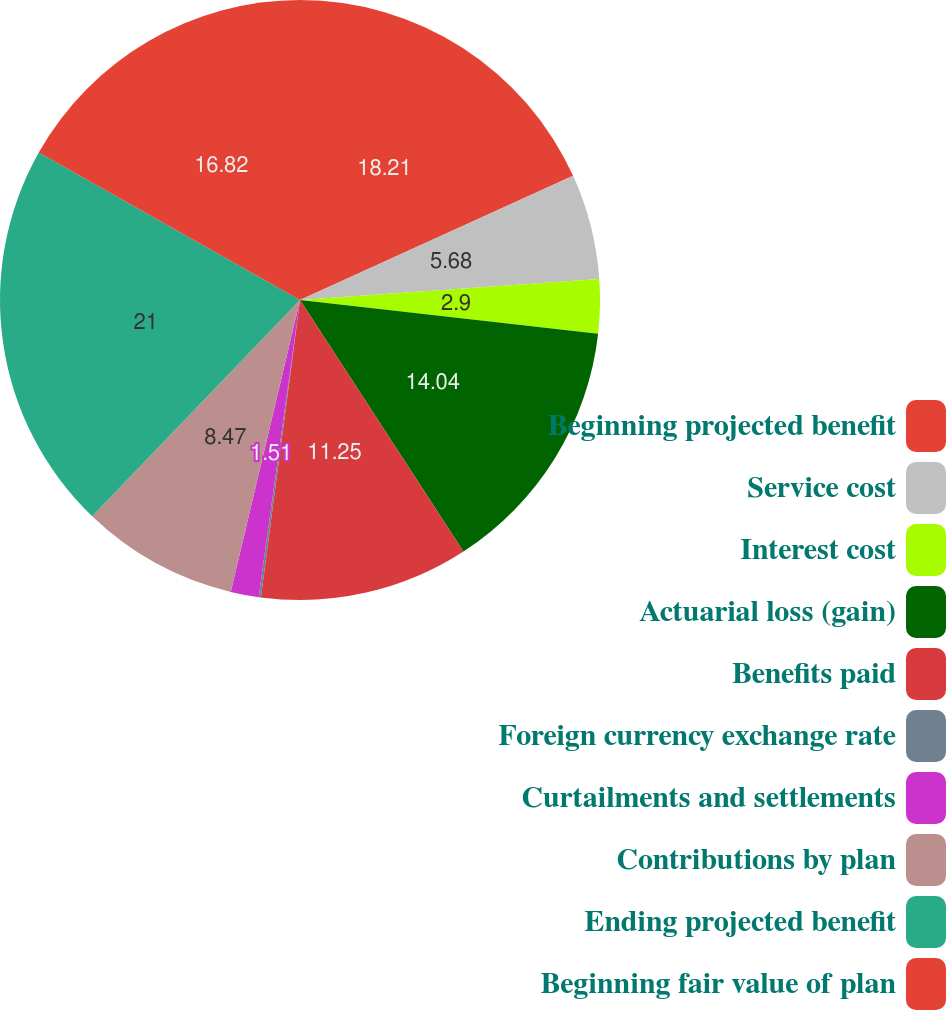<chart> <loc_0><loc_0><loc_500><loc_500><pie_chart><fcel>Beginning projected benefit<fcel>Service cost<fcel>Interest cost<fcel>Actuarial loss (gain)<fcel>Benefits paid<fcel>Foreign currency exchange rate<fcel>Curtailments and settlements<fcel>Contributions by plan<fcel>Ending projected benefit<fcel>Beginning fair value of plan<nl><fcel>18.21%<fcel>5.68%<fcel>2.9%<fcel>14.04%<fcel>11.25%<fcel>0.12%<fcel>1.51%<fcel>8.47%<fcel>21.0%<fcel>16.82%<nl></chart> 